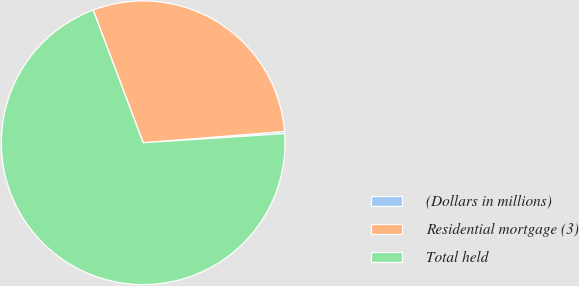<chart> <loc_0><loc_0><loc_500><loc_500><pie_chart><fcel>(Dollars in millions)<fcel>Residential mortgage (3)<fcel>Total held<nl><fcel>0.24%<fcel>29.47%<fcel>70.29%<nl></chart> 